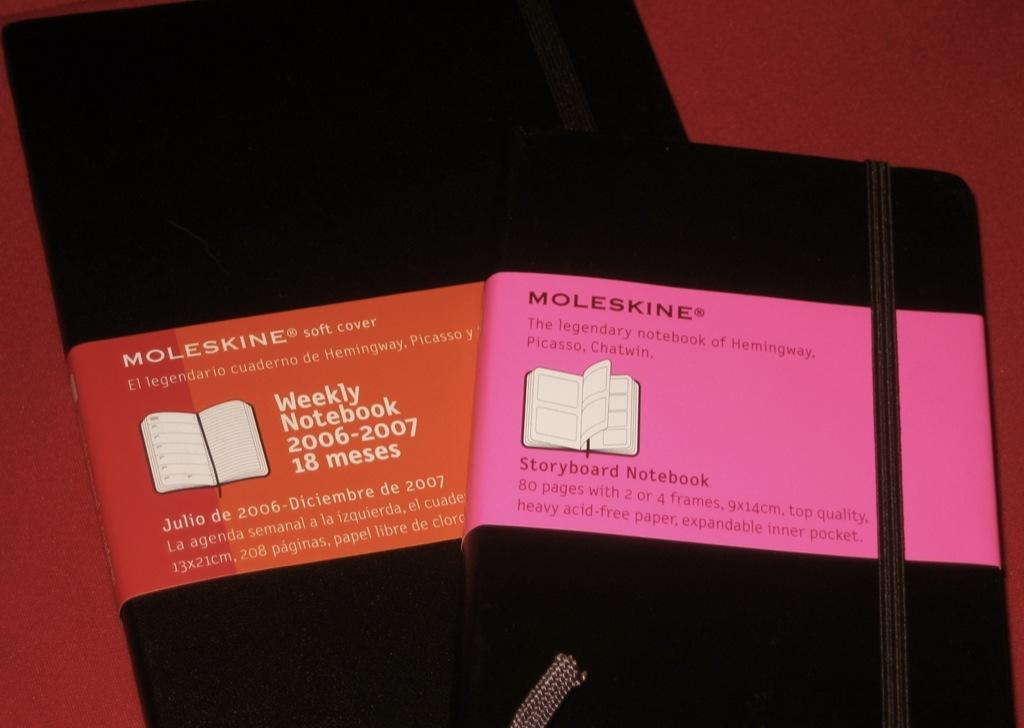<image>
Present a compact description of the photo's key features. The MOLESKINE company produces at least 2 types of notebooks that you could purchase. 